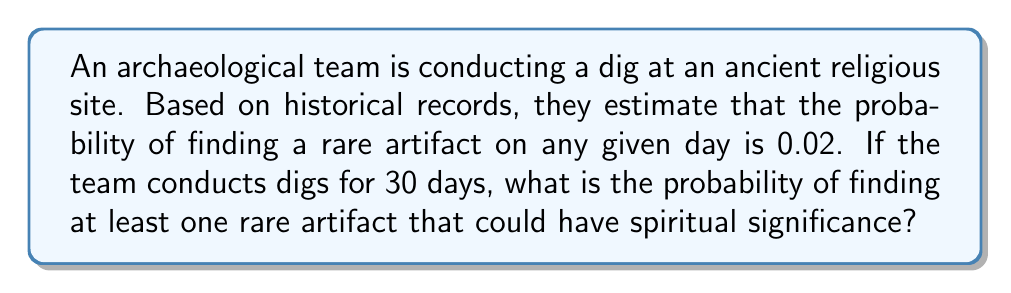Solve this math problem. To solve this problem, we can use the complement of the probability of finding no rare artifacts:

1. Let $p$ be the probability of finding a rare artifact on a single day: $p = 0.02$

2. The probability of not finding a rare artifact on a single day is: $1 - p = 1 - 0.02 = 0.98$

3. For 30 days, the probability of not finding any rare artifacts is:
   $$(0.98)^{30}$$

4. Therefore, the probability of finding at least one rare artifact in 30 days is:
   $$1 - (0.98)^{30}$$

5. Calculate:
   $$1 - (0.98)^{30} \approx 1 - 0.5455 \approx 0.4545$$

6. Convert to percentage:
   $$0.4545 \times 100\% \approx 45.45\%$$

Thus, there is approximately a 45.45% chance of finding at least one rare artifact with potential spiritual significance during the 30-day dig.
Answer: 45.45% 